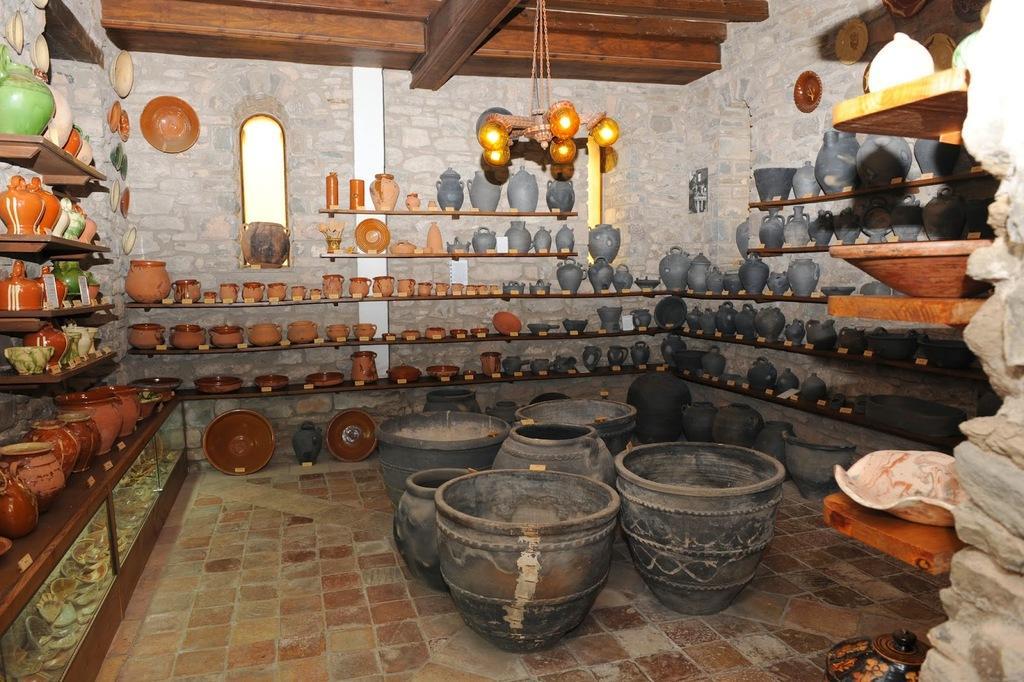Please provide a concise description of this image. In this image we can see objects arranged in shelves. In the background we can see wall and mirror. At the top of the image there is light. 